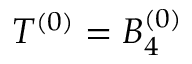<formula> <loc_0><loc_0><loc_500><loc_500>T ^ { ( 0 ) } = B _ { 4 } ^ { ( 0 ) }</formula> 